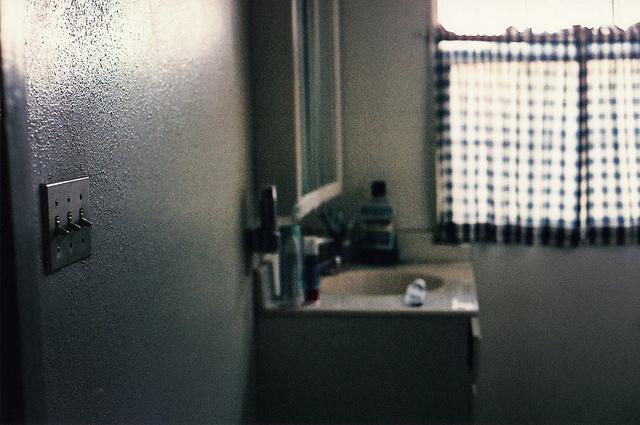What color are the drapes?
Quick response, please. White. Are the curtains checkered?
Be succinct. Yes. Is this a kitchen?
Short answer required. No. What demonstrates the owner of this bathroom cares about their oral health?
Answer briefly. Mouthwash. Do you see a mouthwash?
Quick response, please. Yes. What is the thing with bubbles in it?
Write a very short answer. Nothing. 